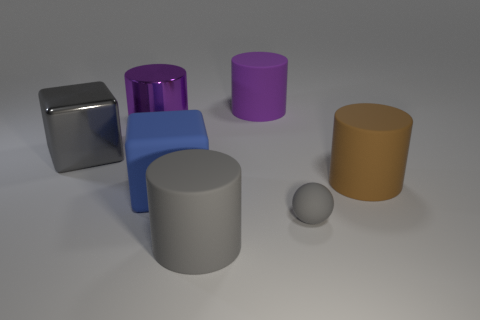Subtract all gray matte cylinders. How many cylinders are left? 3 Add 1 gray metallic balls. How many objects exist? 8 Subtract all purple cylinders. How many cylinders are left? 2 Subtract all blocks. How many objects are left? 5 Subtract 4 cylinders. How many cylinders are left? 0 Subtract all green spheres. How many brown cylinders are left? 1 Subtract all red shiny cylinders. Subtract all gray balls. How many objects are left? 6 Add 2 large blue things. How many large blue things are left? 3 Add 1 big purple rubber things. How many big purple rubber things exist? 2 Subtract 0 red cubes. How many objects are left? 7 